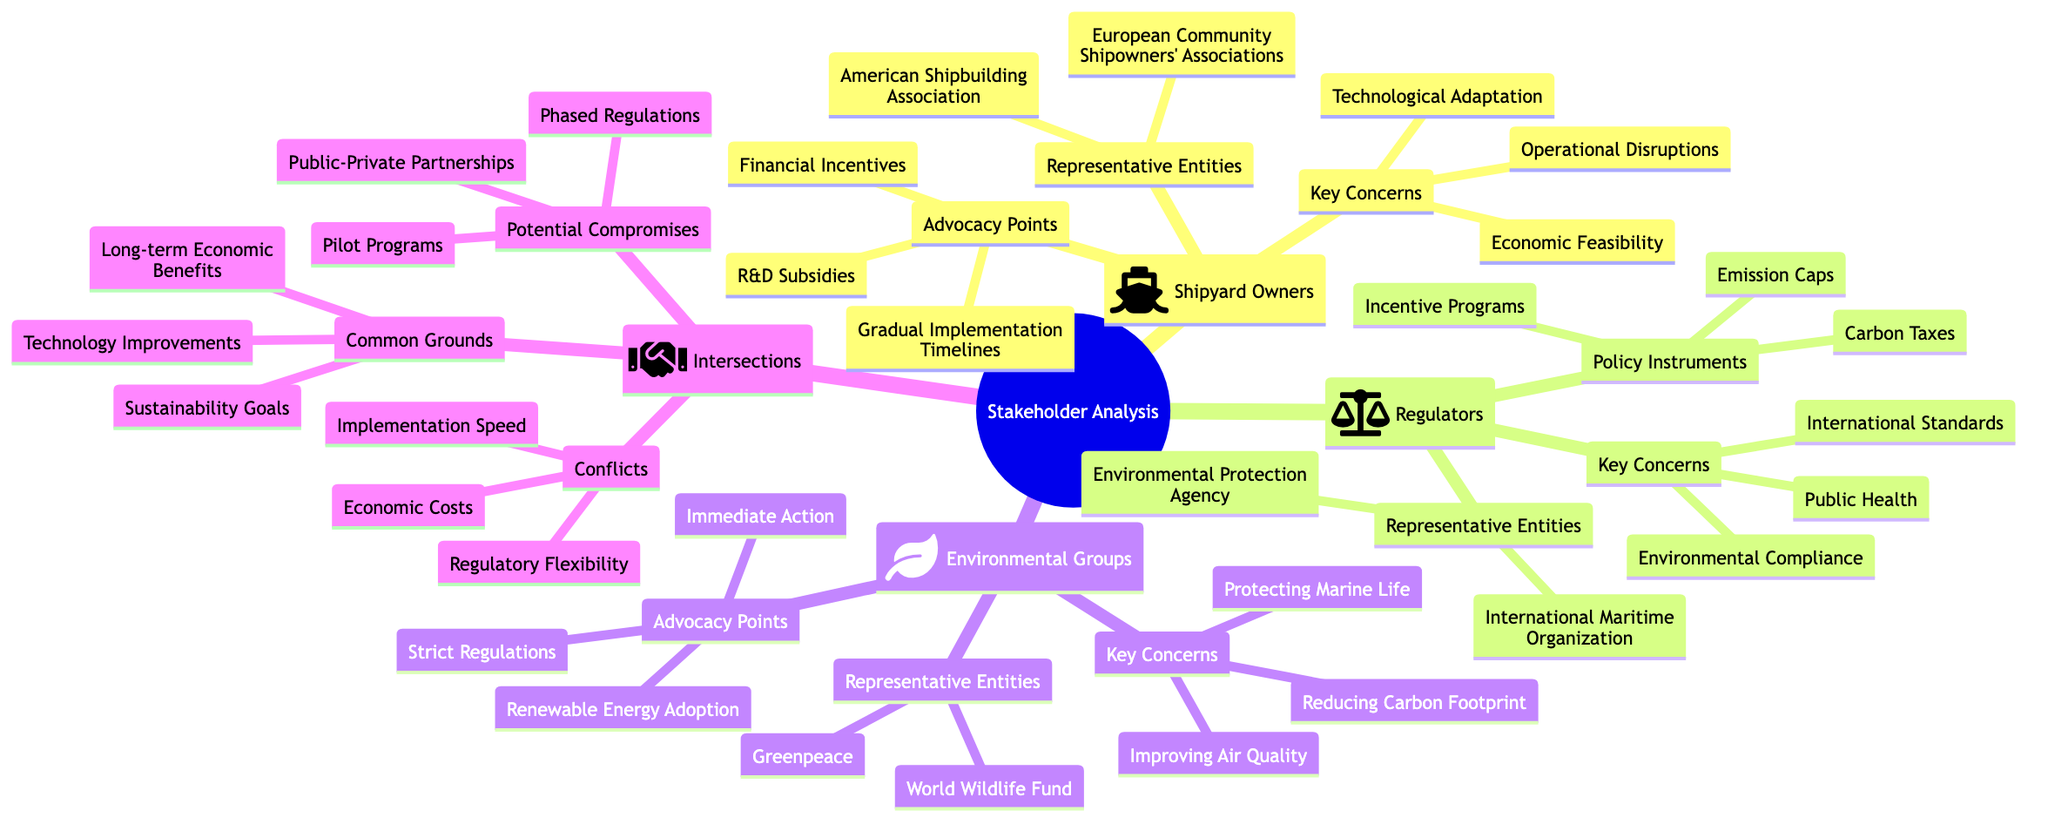What are the key concerns of Shipyard Owners? The diagram specifies three key concerns under the Shipyard Owners section: Economic Feasibility, Technological Adaptation, and Operational Disruptions. This information is directly stated in the Key Concerns node of the Shipyard Owners section.
Answer: Economic Feasibility, Technological Adaptation, Operational Disruptions How many key concerns are listed for Regulators? The diagram shows that there are three key concerns for Regulators: Environmental Compliance, Public Health, and International Standards. This information is in the Key Concerns node for Regulators, confirming that the number of concerns is three.
Answer: 3 What are the common grounds identified in the intersections? The intersections section outlines three common grounds: Sustainability Goals, Technology Improvements, and Long-term Economic Benefits. This implies these are shared interests among all stakeholders. The answer is taken directly from the Common Grounds node.
Answer: Sustainability Goals, Technology Improvements, Long-term Economic Benefits What is one advocacy point from Environmental Groups? The Environmental Groups section lists three advocacy points: Immediate Action, Strict Regulations, and Renewable Energy Adoption. This indicates various proposed actions, and any point could answer this question, but taking one directly states the options.
Answer: Immediate Action What conflicts are mentioned in the intersections? The diagram highlights three conflicts: Implementation Speed, Economic Costs, and Regulatory Flexibility. These conflicts represent disagreements among stakeholders on how to proceed with emissions standards and are listed under the Conflicts node in the intersections section.
Answer: Implementation Speed, Economic Costs, Regulatory Flexibility Which regulatory body is represented by “Environmental Protection Agency”? The Environmental Protection Agency is listed as one of the representative entities for Regulators in the diagram, indicating it plays a significant role in regulatory matters regarding emissions standards.
Answer: Environmental Protection Agency What is a potential compromise suggested in the intersections? The diagram includes three suggestions for potential compromises: Phased Regulations, Pilot Programs, and Public-Private Partnerships. These indicate collaborative efforts for emissions standards implementation and any of these could serve as an answer.
Answer: Phased Regulations What is the main advocacy point of Shipyard Owners? Among the advocacy points listed for Shipyard Owners, one primary point is "Gradual Implementation Timelines", aimed at allowing more time for adaptation. This can be derived directly from the Advocacy Points node in the Shipyard Owners section.
Answer: Gradual Implementation Timelines 